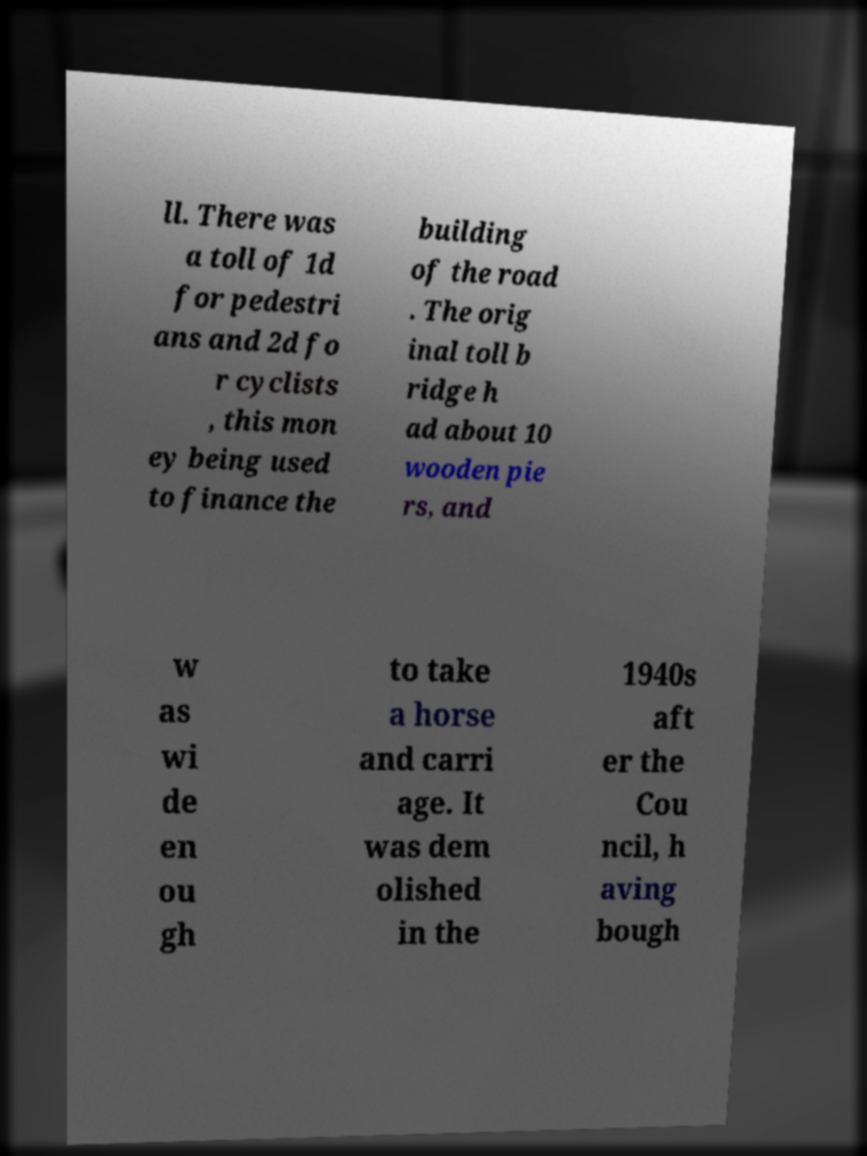I need the written content from this picture converted into text. Can you do that? ll. There was a toll of 1d for pedestri ans and 2d fo r cyclists , this mon ey being used to finance the building of the road . The orig inal toll b ridge h ad about 10 wooden pie rs, and w as wi de en ou gh to take a horse and carri age. It was dem olished in the 1940s aft er the Cou ncil, h aving bough 